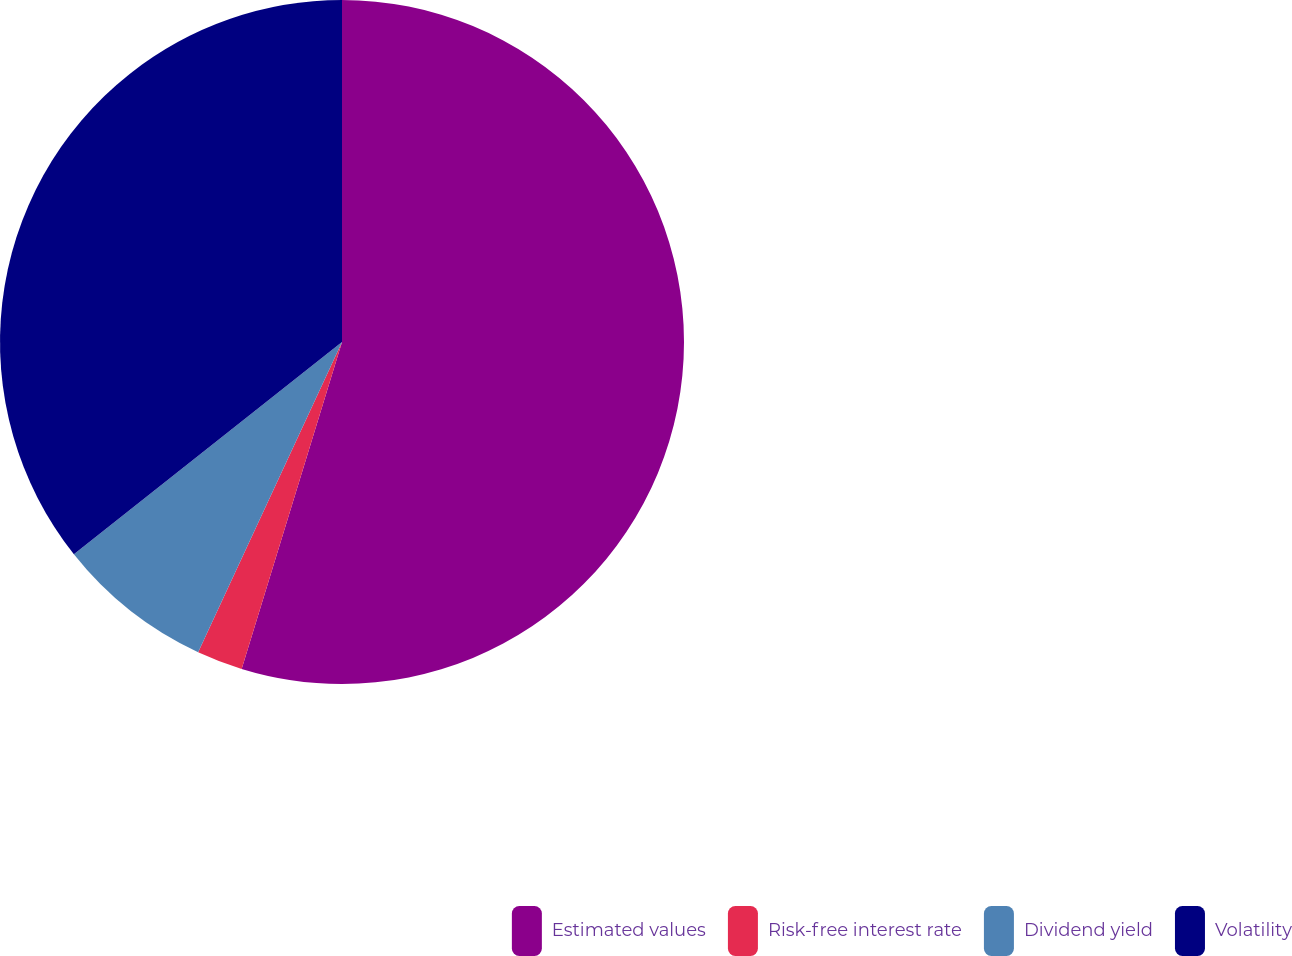Convert chart to OTSL. <chart><loc_0><loc_0><loc_500><loc_500><pie_chart><fcel>Estimated values<fcel>Risk-free interest rate<fcel>Dividend yield<fcel>Volatility<nl><fcel>54.74%<fcel>2.17%<fcel>7.43%<fcel>35.66%<nl></chart> 